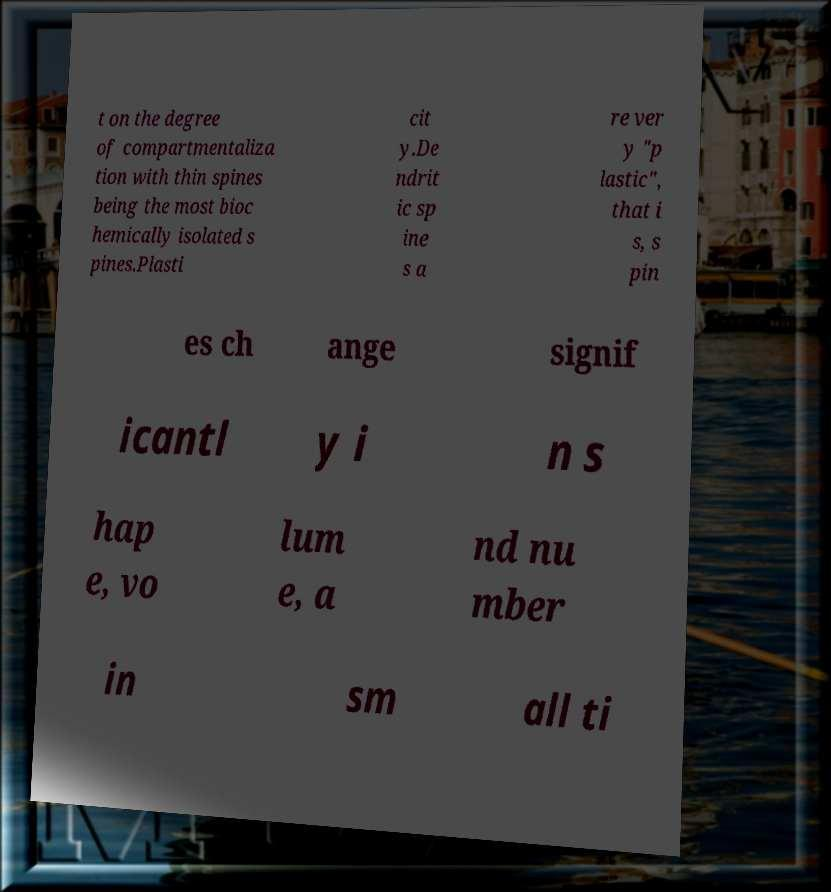Please read and relay the text visible in this image. What does it say? t on the degree of compartmentaliza tion with thin spines being the most bioc hemically isolated s pines.Plasti cit y.De ndrit ic sp ine s a re ver y "p lastic", that i s, s pin es ch ange signif icantl y i n s hap e, vo lum e, a nd nu mber in sm all ti 